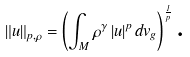Convert formula to latex. <formula><loc_0><loc_0><loc_500><loc_500>\left \| u \right \| _ { p , \rho } = \left ( \int _ { M } \rho ^ { \gamma } \left | u \right | ^ { p } d v _ { g } \right ) ^ { \frac { 1 } { p } } \text {.}</formula> 